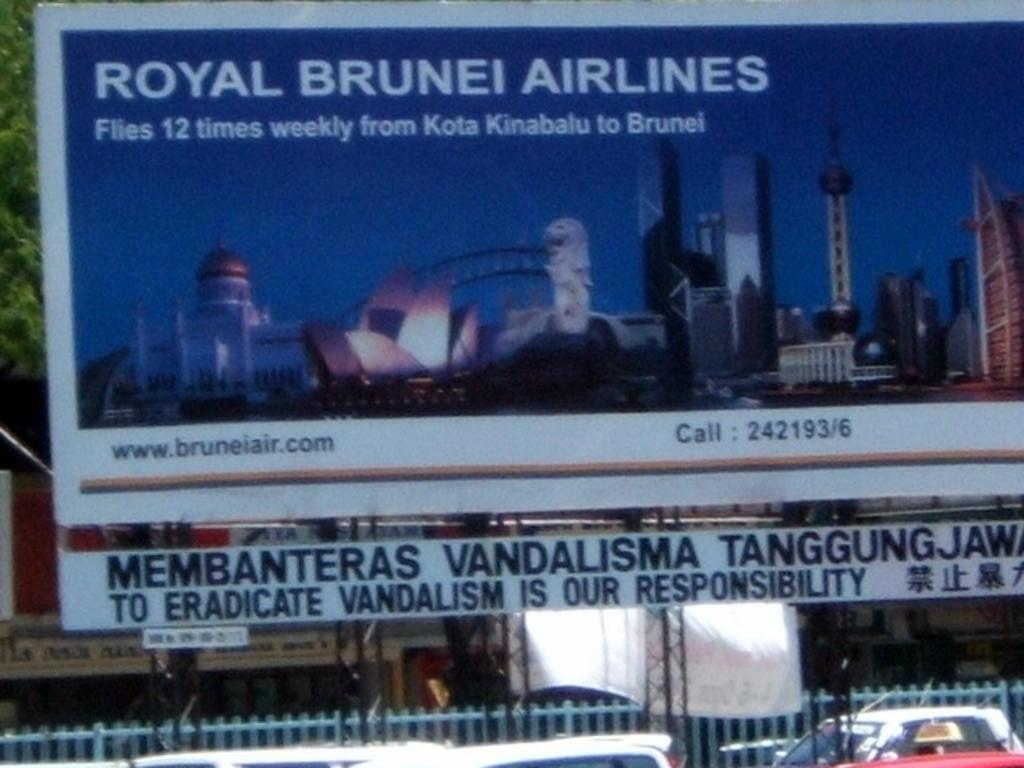<image>
Relay a brief, clear account of the picture shown. A Royal Brunei Airlines advertisement that states how many times they fly from Kota Kinabulu to Brunei. 